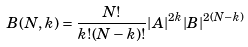<formula> <loc_0><loc_0><loc_500><loc_500>B ( N , k ) = \frac { N ! } { k ! ( N - k ) ! } | A | ^ { 2 k } | B | ^ { 2 ( N - k ) }</formula> 